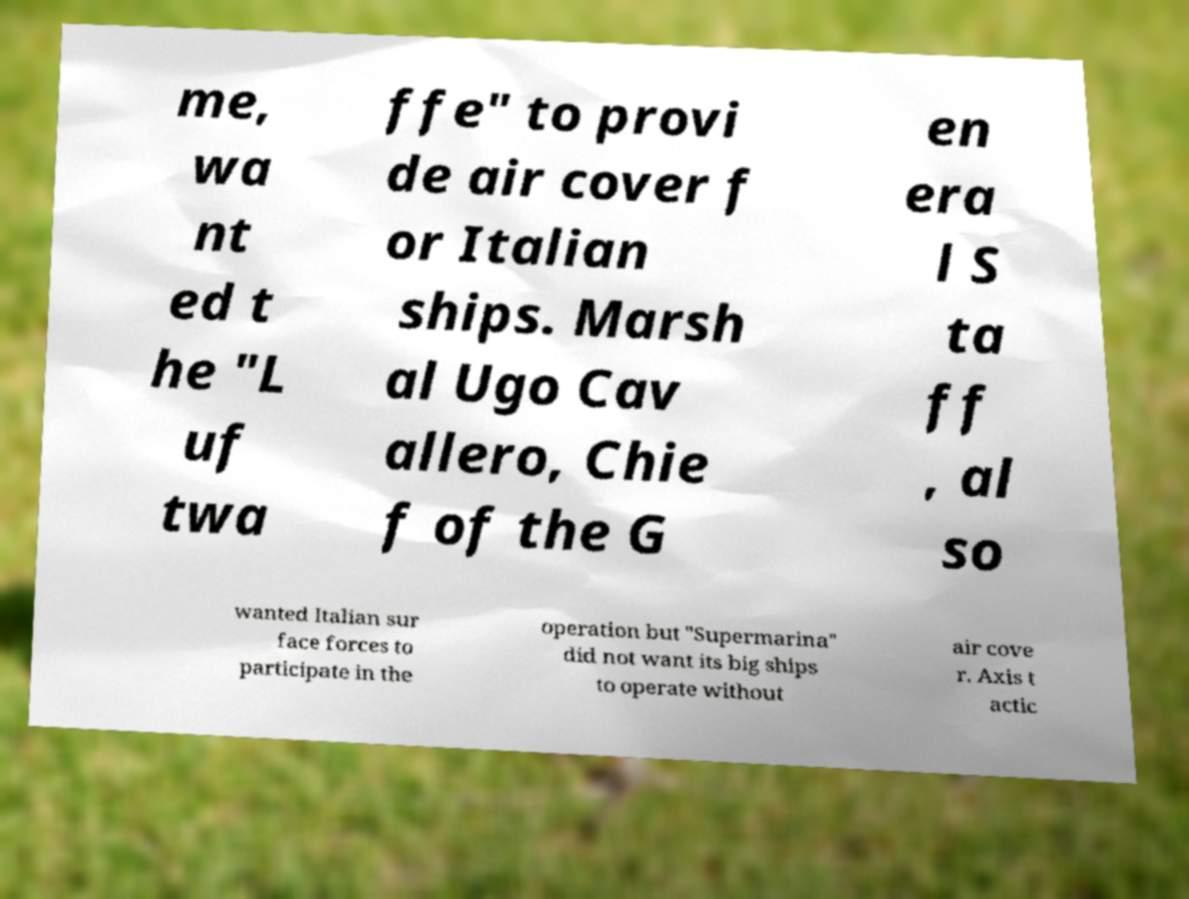Can you accurately transcribe the text from the provided image for me? me, wa nt ed t he "L uf twa ffe" to provi de air cover f or Italian ships. Marsh al Ugo Cav allero, Chie f of the G en era l S ta ff , al so wanted Italian sur face forces to participate in the operation but "Supermarina" did not want its big ships to operate without air cove r. Axis t actic 